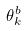<formula> <loc_0><loc_0><loc_500><loc_500>\theta _ { k } ^ { b }</formula> 